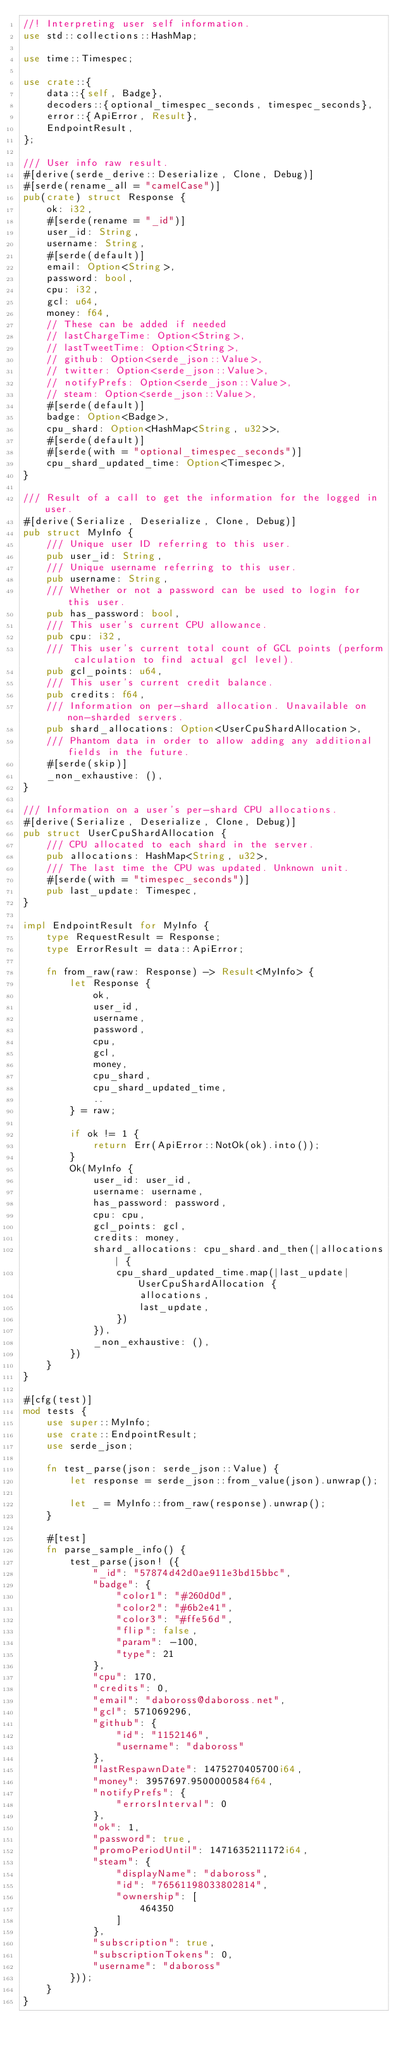<code> <loc_0><loc_0><loc_500><loc_500><_Rust_>//! Interpreting user self information.
use std::collections::HashMap;

use time::Timespec;

use crate::{
    data::{self, Badge},
    decoders::{optional_timespec_seconds, timespec_seconds},
    error::{ApiError, Result},
    EndpointResult,
};

/// User info raw result.
#[derive(serde_derive::Deserialize, Clone, Debug)]
#[serde(rename_all = "camelCase")]
pub(crate) struct Response {
    ok: i32,
    #[serde(rename = "_id")]
    user_id: String,
    username: String,
    #[serde(default)]
    email: Option<String>,
    password: bool,
    cpu: i32,
    gcl: u64,
    money: f64,
    // These can be added if needed
    // lastChargeTime: Option<String>,
    // lastTweetTime: Option<String>,
    // github: Option<serde_json::Value>,
    // twitter: Option<serde_json::Value>,
    // notifyPrefs: Option<serde_json::Value>,
    // steam: Option<serde_json::Value>,
    #[serde(default)]
    badge: Option<Badge>,
    cpu_shard: Option<HashMap<String, u32>>,
    #[serde(default)]
    #[serde(with = "optional_timespec_seconds")]
    cpu_shard_updated_time: Option<Timespec>,
}

/// Result of a call to get the information for the logged in user.
#[derive(Serialize, Deserialize, Clone, Debug)]
pub struct MyInfo {
    /// Unique user ID referring to this user.
    pub user_id: String,
    /// Unique username referring to this user.
    pub username: String,
    /// Whether or not a password can be used to login for this user.
    pub has_password: bool,
    /// This user's current CPU allowance.
    pub cpu: i32,
    /// This user's current total count of GCL points (perform calculation to find actual gcl level).
    pub gcl_points: u64,
    /// This user's current credit balance.
    pub credits: f64,
    /// Information on per-shard allocation. Unavailable on non-sharded servers.
    pub shard_allocations: Option<UserCpuShardAllocation>,
    /// Phantom data in order to allow adding any additional fields in the future.
    #[serde(skip)]
    _non_exhaustive: (),
}

/// Information on a user's per-shard CPU allocations.
#[derive(Serialize, Deserialize, Clone, Debug)]
pub struct UserCpuShardAllocation {
    /// CPU allocated to each shard in the server.
    pub allocations: HashMap<String, u32>,
    /// The last time the CPU was updated. Unknown unit.
    #[serde(with = "timespec_seconds")]
    pub last_update: Timespec,
}

impl EndpointResult for MyInfo {
    type RequestResult = Response;
    type ErrorResult = data::ApiError;

    fn from_raw(raw: Response) -> Result<MyInfo> {
        let Response {
            ok,
            user_id,
            username,
            password,
            cpu,
            gcl,
            money,
            cpu_shard,
            cpu_shard_updated_time,
            ..
        } = raw;

        if ok != 1 {
            return Err(ApiError::NotOk(ok).into());
        }
        Ok(MyInfo {
            user_id: user_id,
            username: username,
            has_password: password,
            cpu: cpu,
            gcl_points: gcl,
            credits: money,
            shard_allocations: cpu_shard.and_then(|allocations| {
                cpu_shard_updated_time.map(|last_update| UserCpuShardAllocation {
                    allocations,
                    last_update,
                })
            }),
            _non_exhaustive: (),
        })
    }
}

#[cfg(test)]
mod tests {
    use super::MyInfo;
    use crate::EndpointResult;
    use serde_json;

    fn test_parse(json: serde_json::Value) {
        let response = serde_json::from_value(json).unwrap();

        let _ = MyInfo::from_raw(response).unwrap();
    }

    #[test]
    fn parse_sample_info() {
        test_parse(json! ({
            "_id": "57874d42d0ae911e3bd15bbc",
            "badge": {
                "color1": "#260d0d",
                "color2": "#6b2e41",
                "color3": "#ffe56d",
                "flip": false,
                "param": -100,
                "type": 21
            },
            "cpu": 170,
            "credits": 0,
            "email": "daboross@daboross.net",
            "gcl": 571069296,
            "github": {
                "id": "1152146",
                "username": "daboross"
            },
            "lastRespawnDate": 1475270405700i64,
            "money": 3957697.9500000584f64,
            "notifyPrefs": {
                "errorsInterval": 0
            },
            "ok": 1,
            "password": true,
            "promoPeriodUntil": 1471635211172i64,
            "steam": {
                "displayName": "daboross",
                "id": "76561198033802814",
                "ownership": [
                    464350
                ]
            },
            "subscription": true,
            "subscriptionTokens": 0,
            "username": "daboross"
        }));
    }
}
</code> 